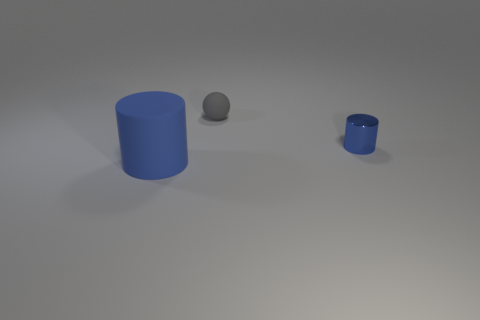Are there any other things that are the same shape as the blue metallic object? Yes, there is another object that shares the cylindrical shape with the blue metallic one. It's a smaller cylinder, also colored blue but with a slightly different hue and a metallic finish, positioned to the right of the larger cylinder. 